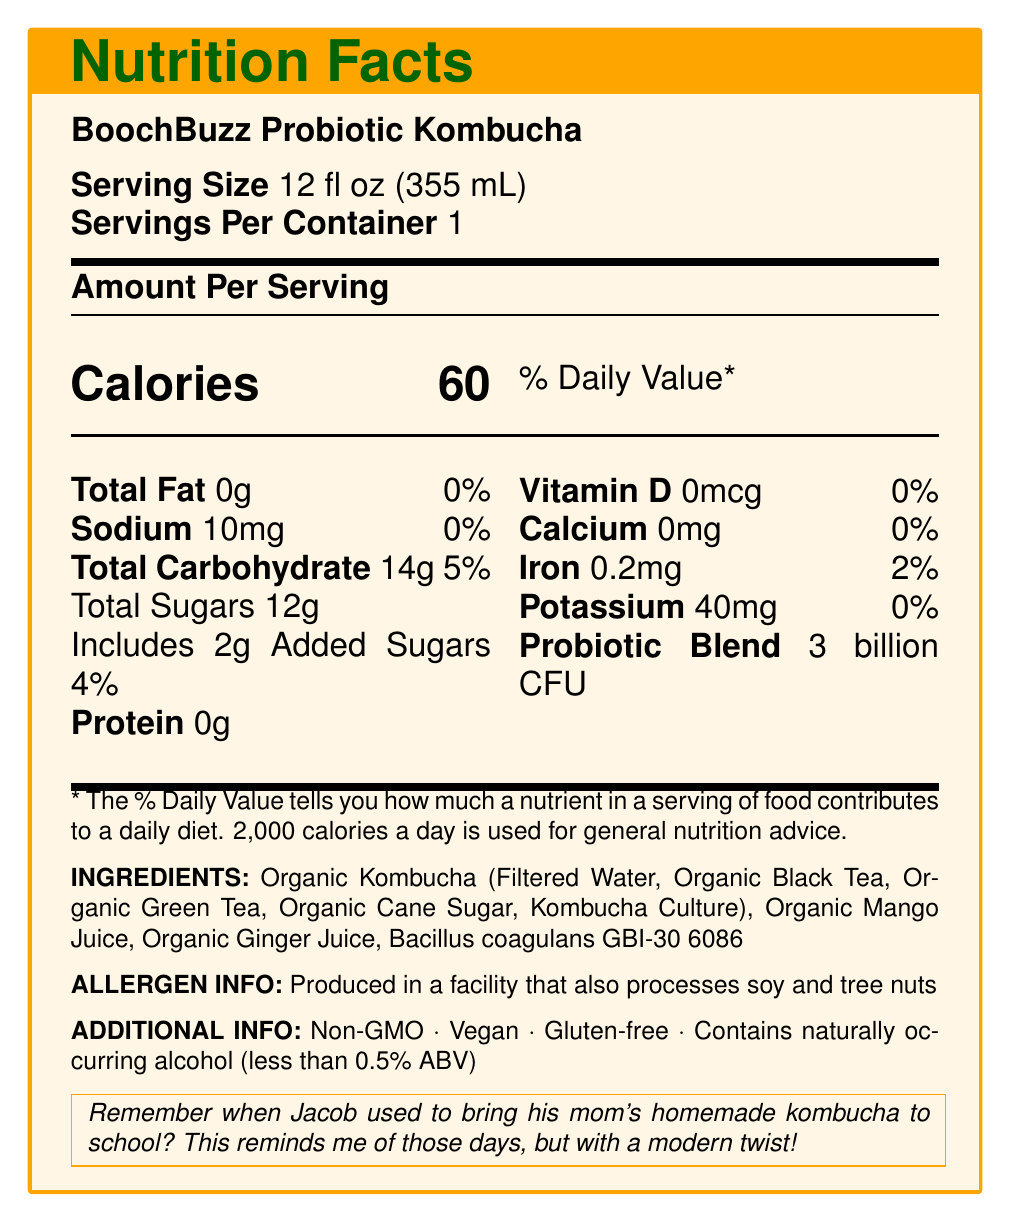what is the serving size? The serving size is directly mentioned under "Serving Size" on the nutrition label.
Answer: 12 fl oz (355 mL) how many servings are in the container? The label states there is "Servings Per Container: 1".
Answer: 1 how many calories are in one serving? The calories per serving are clearly indicated as 60 in large font.
Answer: 60 what is the total carbohydrate content in one serving? The total carbohydrate is listed as 14g under the "Total Carbohydrate" section.
Answer: 14g what is the amount of sodium in one serving? Sodium content is listed as 10mg on the nutrition label.
Answer: 10mg what are the main ingredients in this kombucha? The main ingredients are specified in the "Ingredients" section of the label.
Answer: Organic Kombucha (Filtered Water, Organic Black Tea, Organic Green Tea, Organic Cane Sugar, Kombucha Culture), Organic Mango Juice, Organic Ginger Juice, Bacillus coagulans GBI-30 6086 how much iron is in one serving? The iron content is listed as 0.2mg on the nutrition label.
Answer: 0.2mg what is the amount of added sugars per serving? The added sugars are stated to be 2g under the "Total Sugars" section.
Answer: 2g what is the Probiotic Blend amount in this product? The Probiotic Blend content is mentioned as "3 billion CFU" next to other nutrient information.
Answer: 3 billion CFU which of the following nutrients is present in the highest quantity per serving? 
a. Sodium 
b. Total Sugars 
c. Iron 
d. Potassium Total Sugars are 12g, which is higher compared to Sodium (10mg), Iron (0.2mg), and Potassium (40mg).
Answer: b. Total Sugars what type of additional information is provided about BoochBuzz Probiotic Kombucha?
a. Non-GMO, Vegan, Gluten-free, Contains naturally occurring alcohol
b. Contains Artificial Sweeteners, Kosher, Sugar-free, High Protein
c. Low Fat, High Fiber, Rich in Vitamin C, Organic
d. Contains Dairy, High Calorie, High Sodium, Imported The additional information section mentions that the product is Non-GMO, Vegan, Gluten-free, and contains naturally occurring alcohol.
Answer: a. Non-GMO, Vegan, Gluten-free, Contains naturally occurring alcohol is this kombucha drink suitable for someone with a tree nut allergy? The allergen information states it is produced in a facility that also processes tree nuts.
Answer: No does this product contain any vitamin D? The vitamin D content is listed as 0mcg, with 0% daily value.
Answer: No summarize the nutrition facts for BoochBuzz Probiotic Kombucha. The summary includes all relevant nutrient details, additional product information, and allergen warning from the document.
Answer: BoochBuzz Probiotic Kombucha has a nutrient profile per 12 fl oz serving, containing 60 calories, 0g total fat, 10mg sodium, 14g total carbohydrate (including 12g total sugars and 2g added sugars), and 0g protein. It includes a probiotic blend of 3 billion CFU. Additionally, it contains 0mcg vitamin D, 0mg calcium, 0.2mg iron, and 40mg potassium. The ingredients are primarily organic and it is Non-GMO, Vegan, and Gluten-free with a warning about potential allergen cross-contact with soy and tree nuts. how many grams of protein are in one serving? The amount of protein is listed as 0g on the nutrition label.
Answer: 0g what is the main source of flavor in this kombucha? The document does not specify the main source of flavor. It only lists the ingredients but doesn’t detail which ingredient contributes most to the flavor profile.
Answer: Cannot be determined 